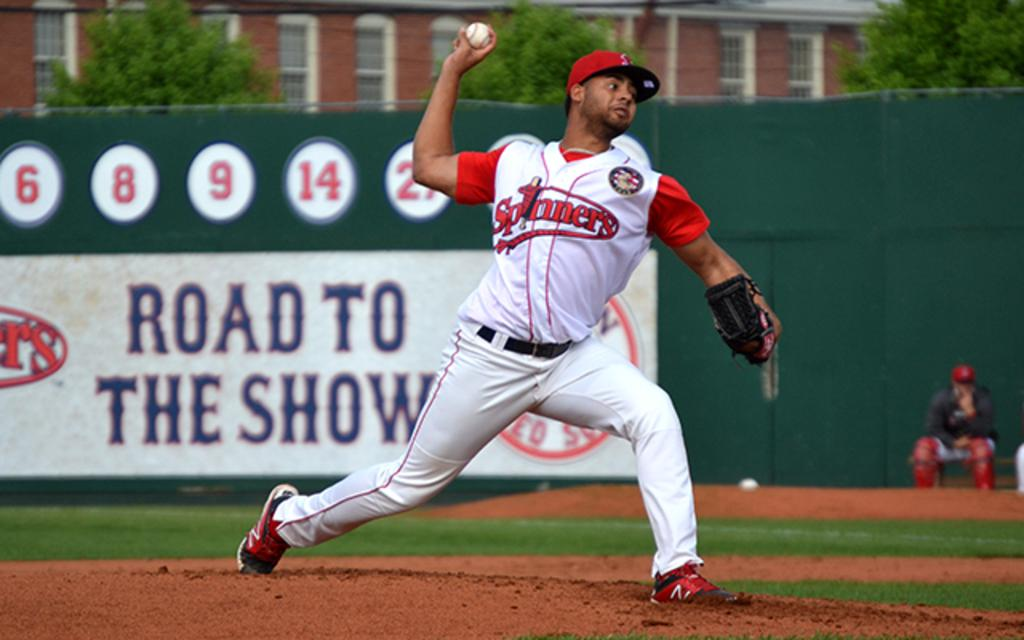<image>
Describe the image concisely. a road to the show sign with a team playing 